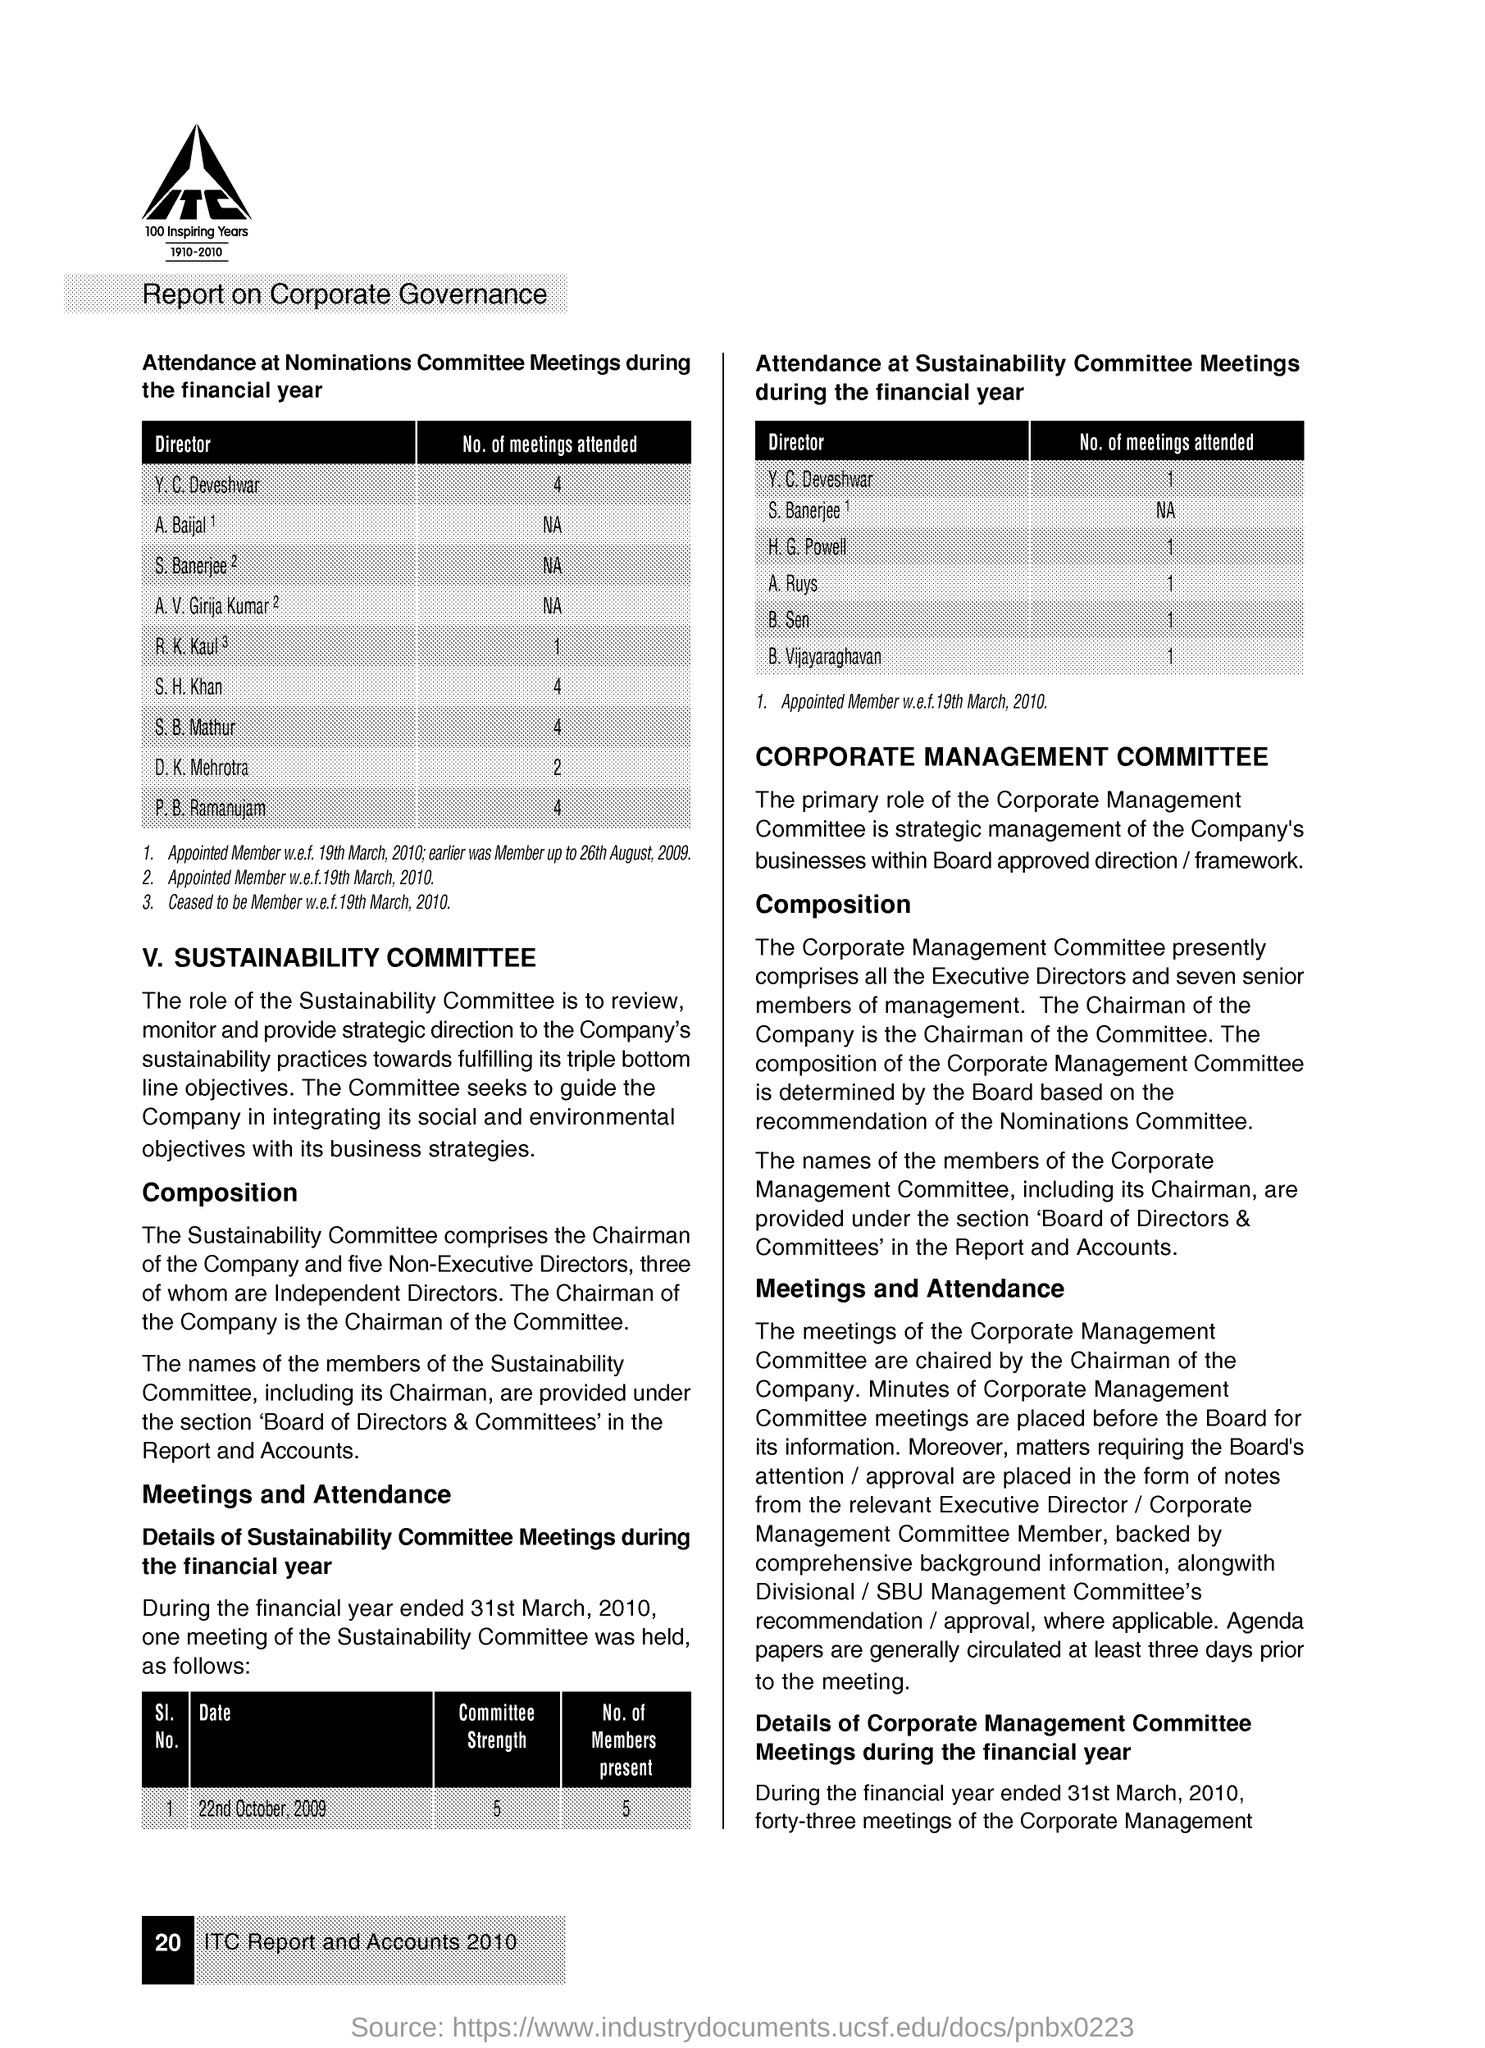What is the title of the document?
Provide a succinct answer. Report on Corporate Governance. 